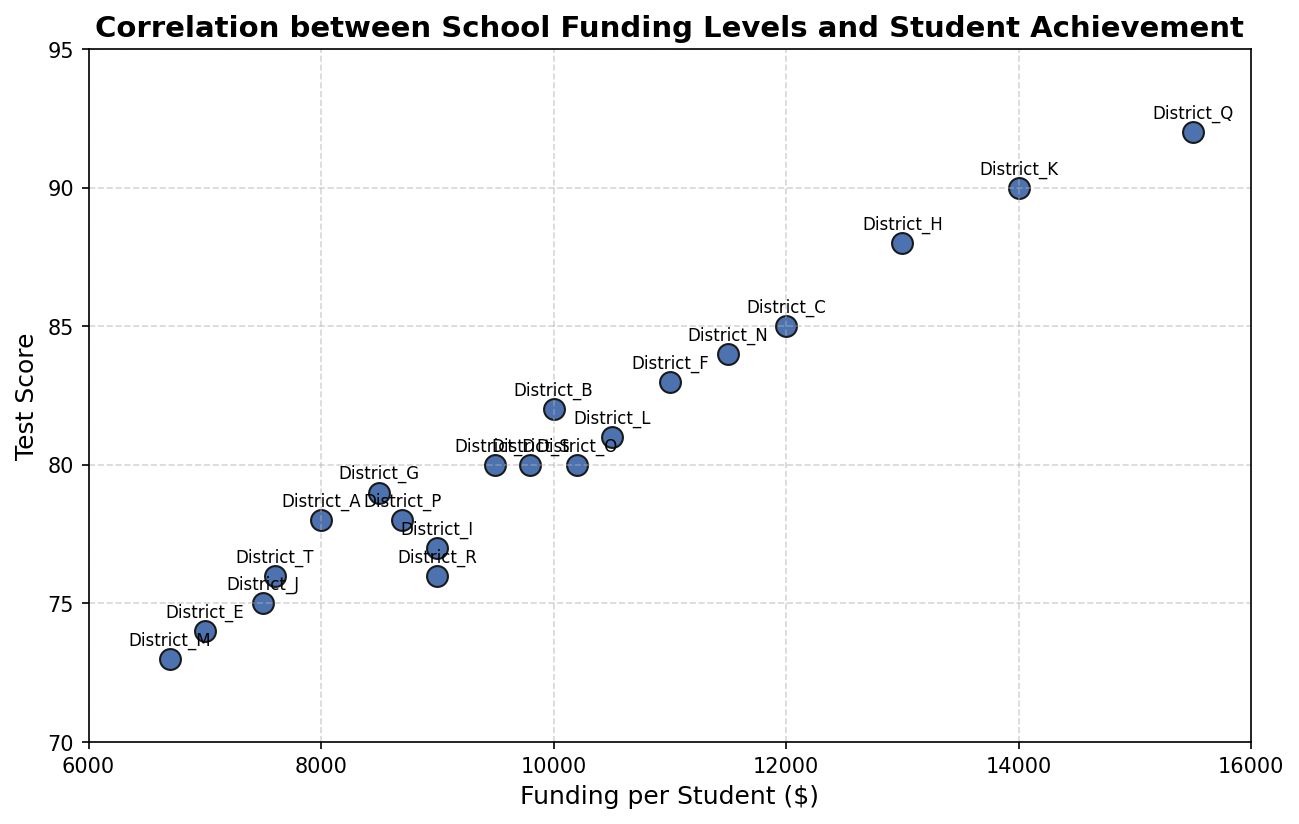Which district has the highest level of funding per student? The highest level of funding per student can be determined by looking for the data point with the highest x-coordinate. District Q has the highest funding level at $15,500 per student.
Answer: District Q How many districts have funding levels below $10,000 per student and test scores above 80? To answer this, identify the data points where the x-coordinate is less than $10,000 and the y-coordinate is greater than 80. Districts B, D, and K fit this criteria.
Answer: 3 districts Which district has the lowest test score, and what is its funding level? Identify the data point with the lowest y-coordinate. District M has the lowest score at 73, with a funding level of $6,700 per student.
Answer: District M, $6,700 What is the average test score for districts funding more than $10,000 per student? Identify the districts with funding more than $10,000 and calculate the average test score. Districts: C (85), F (83), H (88), K (90), N (84), Q (92). The sum is 85 + 83 + 88 + 90 + 84 + 92 = 522. The average is 522 / 6 = 87.
Answer: 87 Compare the test scores of District T and District J. Which one is higher? Look at the y-coordinates for District T and District J. District J has a test score of 75 while District T has a score of 76, so District T has a higher test score.
Answer: District T What is the total funding for Districts A, H, and Q combined? Add the funding levels of District A ($8,000), District H ($13,000), and District Q ($15,500). The sum is 8,000 + 13,000 + 15,500 = $36,500.
Answer: $36,500 Are there any districts with identical test scores but different funding levels? Check if any data points have the same y-coordinate but different x-coordinates. District O and District S both have a test score of 80 but different funding levels of $10,200 and $9,800, respectively.
Answer: Yes, District O and District S What is the funding level of the district positioned in the middle when sorted by test scores? First, sort the districts by their test scores and find the median district. Since there are 20 districts, the median is the average of the 10th and 11th. District R (76) and District T (76) are the 10th and 11th, so the median test score is 76. Both R and T have funding levels of $9,000 and $7,600, respectively. The middle funding level is the average, ($9,000 + $7,600)/2 = $8,300.
Answer: $8,300 Which district saw the greatest increase in test score compared to District E with a funding increase more than $3,000? To find this, compare the test scores of districts with funding greater than $7,000 + $3,000 ($10,000) and identify the highest increase. For example, District Q with $15,500 saw an increase of 92 - 74 = 18.
Answer: District Q Is District L above or below the average test score for its funding level? District L has funding of $10,500 and a test score of 81. First, find the test scores of districts near this funding level: District L (81), District F ($11,000, 83), and District N ($11,500, 84). The average is (81+83+84)/3 = 82.67. District L is below the average of 82.67.
Answer: Below 